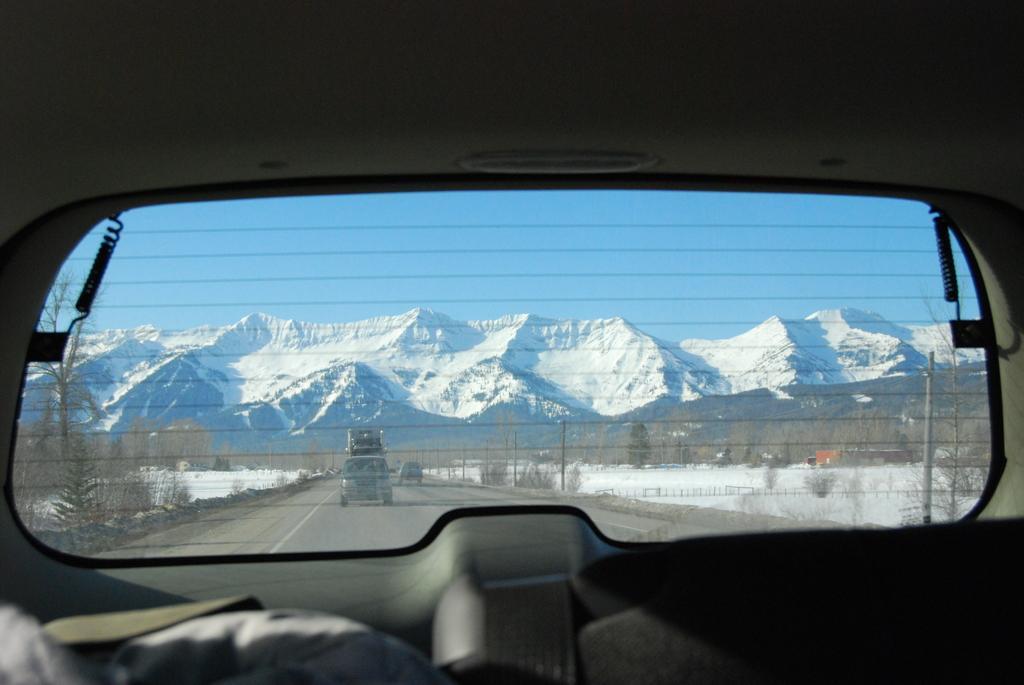Can you describe this image briefly? This picture is taken inside a vehicle. Few vehicles are on the road. On both sides of the road there are few plants and trees on the land which is covered with snow. Background there are few hills. Top of it there is sky. 